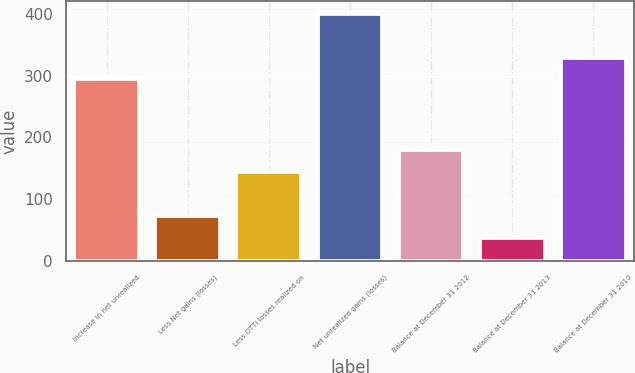Convert chart to OTSL. <chart><loc_0><loc_0><loc_500><loc_500><bar_chart><fcel>Increase in net unrealized<fcel>Less Net gains (losses)<fcel>Less OTTI losses realized on<fcel>Net unrealized gains (losses)<fcel>Balance at December 31 2012<fcel>Balance at December 31 2013<fcel>Balance at December 31 2010<nl><fcel>294<fcel>72.8<fcel>143.6<fcel>400.2<fcel>179<fcel>37.4<fcel>329.4<nl></chart> 